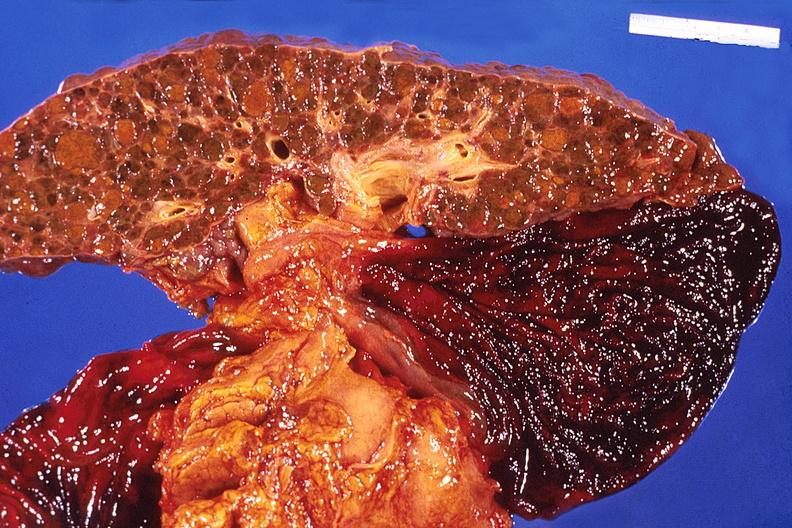s hepatobiliary present?
Answer the question using a single word or phrase. Yes 